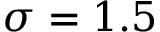Convert formula to latex. <formula><loc_0><loc_0><loc_500><loc_500>\sigma = 1 . 5</formula> 